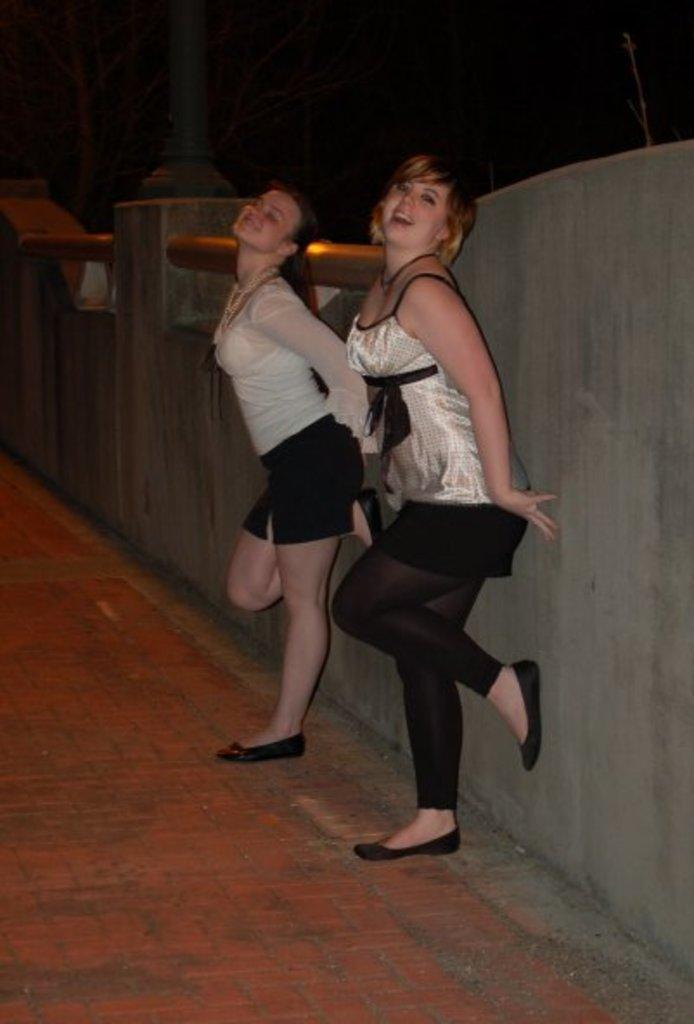How many people are in the image? There are two women in the image. What are the women doing in the image? The women are leaning against a wall. What is visible beneath the women in the image? There is a floor visible in the image. What can be seen in the background of the image? There is a pole in the background of the image, and the background is dark. What type of fear is the woman on the left experiencing in the image? There is no indication of fear in the image; the women are simply leaning against a wall. How many passengers are visible in the image? There are no passengers present in the image, only two women. 